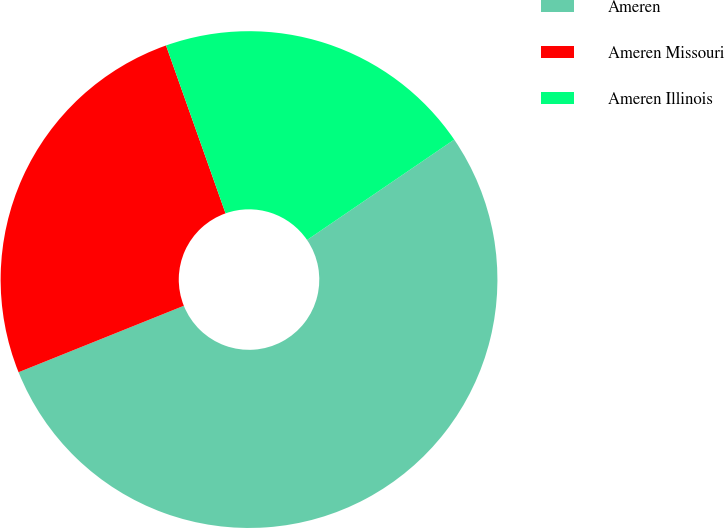<chart> <loc_0><loc_0><loc_500><loc_500><pie_chart><fcel>Ameren<fcel>Ameren Missouri<fcel>Ameren Illinois<nl><fcel>53.44%<fcel>25.66%<fcel>20.89%<nl></chart> 